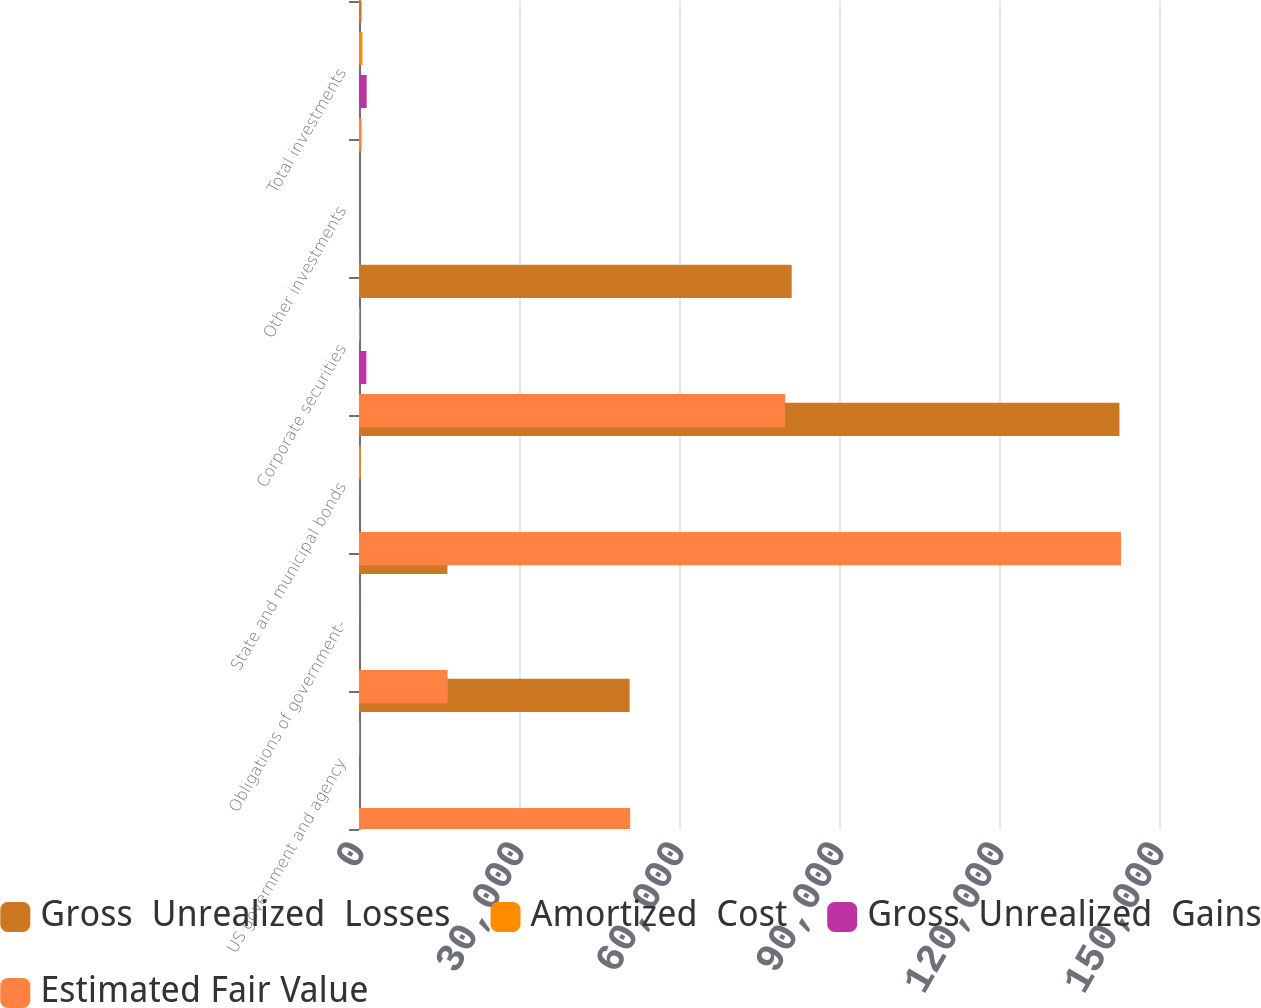<chart> <loc_0><loc_0><loc_500><loc_500><stacked_bar_chart><ecel><fcel>US government and agency<fcel>Obligations of government-<fcel>State and municipal bonds<fcel>Corporate securities<fcel>Other investments<fcel>Total investments<nl><fcel>Gross  Unrealized  Losses<fcel>50738<fcel>16581<fcel>142586<fcel>81132<fcel>36<fcel>485.5<nl><fcel>Amortized  Cost<fcel>115<fcel>32<fcel>330<fcel>164<fcel>0<fcel>641<nl><fcel>Gross  Unrealized  Gains<fcel>6<fcel>1<fcel>43<fcel>1387<fcel>0<fcel>1437<nl><fcel>Estimated Fair Value<fcel>50847<fcel>16612<fcel>142873<fcel>79909<fcel>36<fcel>485.5<nl></chart> 